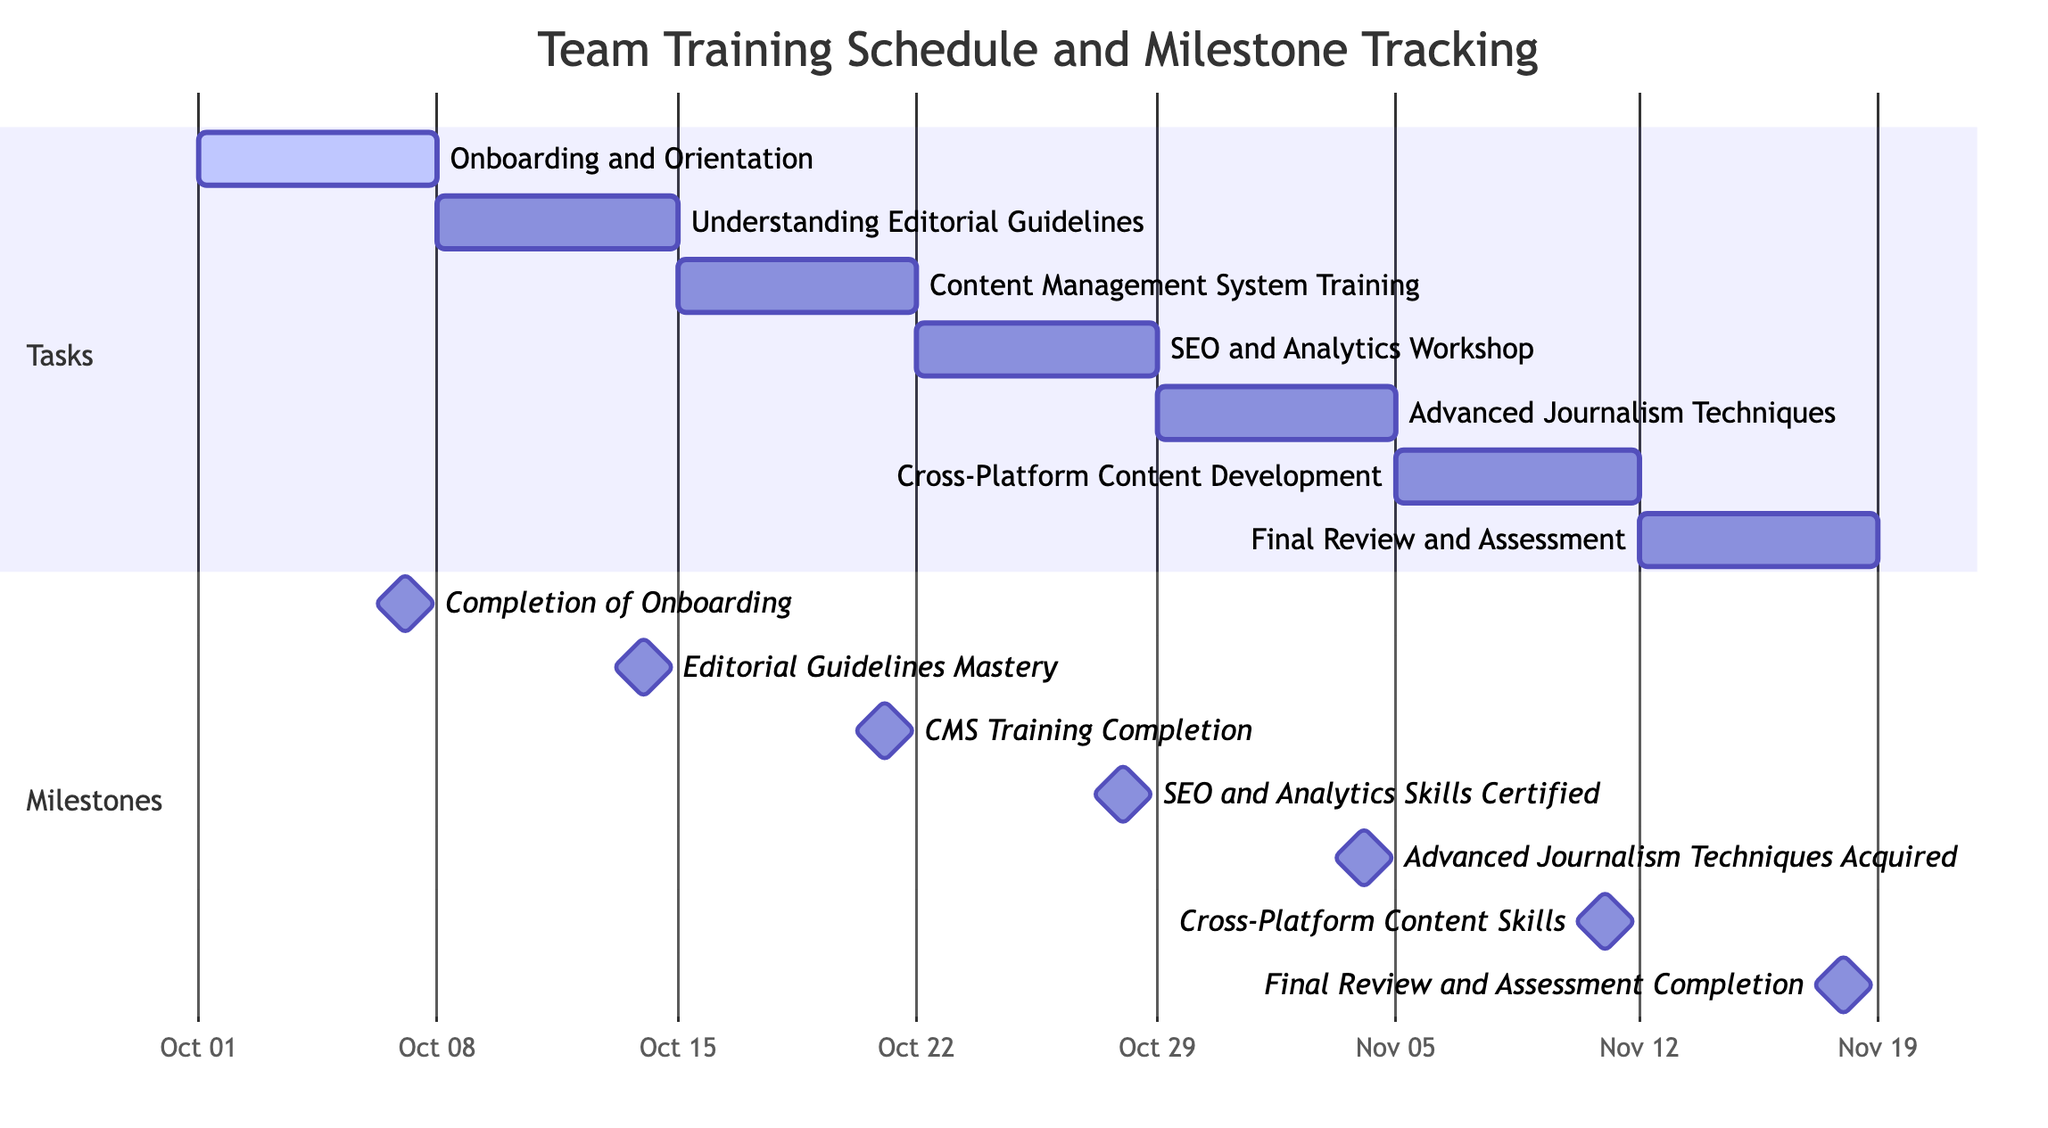What is the duration of the "SEO and Analytics Workshop"? The start date for the "SEO and Analytics Workshop" is October 22, 2023, and the end date is October 28, 2023. The duration can be calculated by subtracting the start date from the end date, which results in 7 days.
Answer: 7 days What is the dependency for "Advanced Journalism Techniques"? The "Advanced Journalism Techniques" task has one dependency, which is "SEO and Analytics Workshop". This means that it can only start after the completion of the previous task.
Answer: SEO and Analytics Workshop How many milestones are tracked in this Gantt chart? The diagram includes a section for milestones, listing seven separate milestones indicating key achievements throughout the training schedule.
Answer: 7 What is the completion date for "Final Review and Assessment"? The "Final Review and Assessment" task ends on November 18, 2023, which is specified directly in the chart as its end date.
Answer: November 18, 2023 What is the last task in the training schedule? The last task in the sequence, following the established flow in the Gantt chart, is "Final Review and Assessment", which concludes the training schedule as the final task.
Answer: Final Review and Assessment Which task follows "Content Management System Training"? The task that follows "Content Management System Training" is "SEO and Analytics Workshop". This follows the sequence of tasks as depicted in the diagram.
Answer: SEO and Analytics Workshop When does the training schedule start? The training schedule starts on October 1, 2023, which is the start date of the first task, "Onboarding and Orientation".
Answer: October 1, 2023 What milestone is associated with the "Understanding Editorial Guidelines" task? The milestone associated with the "Understanding Editorial Guidelines" task is "Editorial Guidelines Mastery", which is achieved upon completion of that task.
Answer: Editorial Guidelines Mastery Which task has the most upcoming milestone? The next milestone in the schedule after the current date (considering the timeline) pertains to "CMS Training Completion", which is reached after completing "Content Management System Training".
Answer: CMS Training Completion 